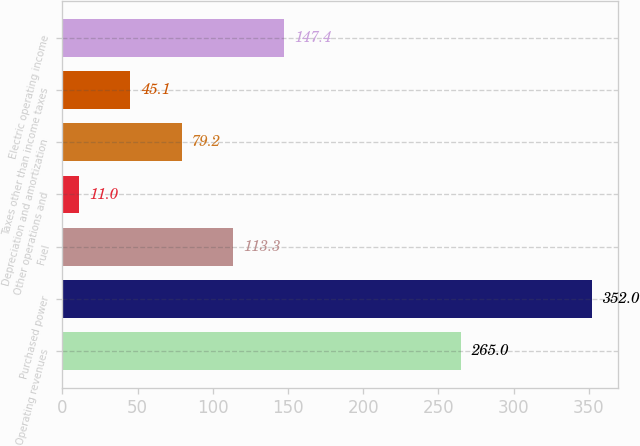<chart> <loc_0><loc_0><loc_500><loc_500><bar_chart><fcel>Operating revenues<fcel>Purchased power<fcel>Fuel<fcel>Other operations and<fcel>Depreciation and amortization<fcel>Taxes other than income taxes<fcel>Electric operating income<nl><fcel>265<fcel>352<fcel>113.3<fcel>11<fcel>79.2<fcel>45.1<fcel>147.4<nl></chart> 